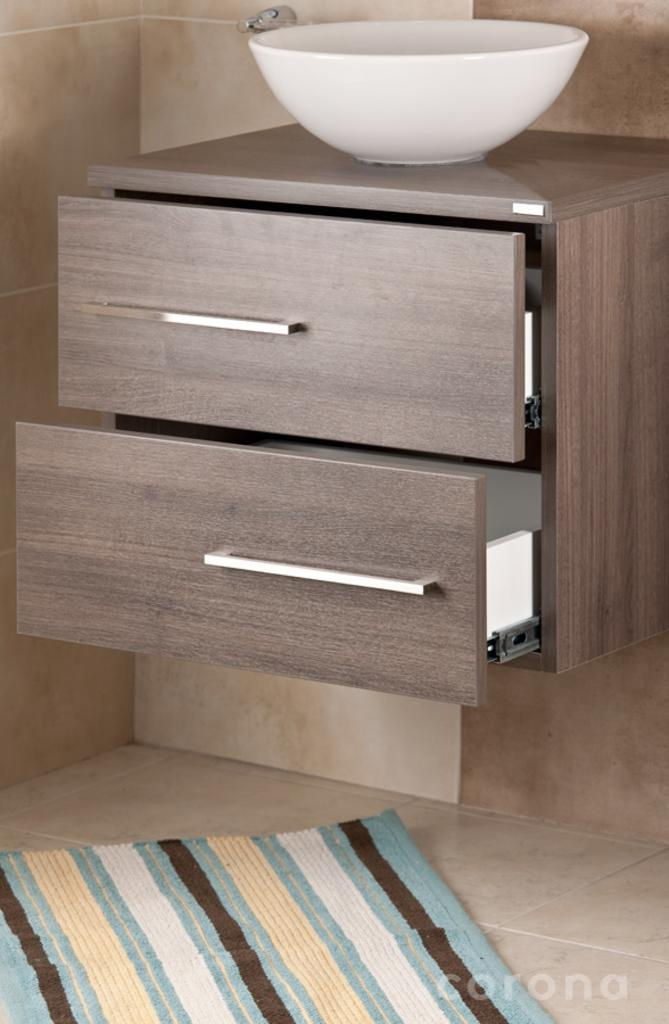What type of floor covering is visible in the image? There is a carpet on the floor in the image. What is located on the wall behind the carpet? There are drawers on the wall behind the carpet. What object is placed on the drawers? There is a bowl on the drawers. Can you describe any additional features of the image? The image has a watermark. Where is the basin located in the image? There is no basin present in the image. What type of knife can be seen on the desk in the image? There is no desk or knife present in the image. 